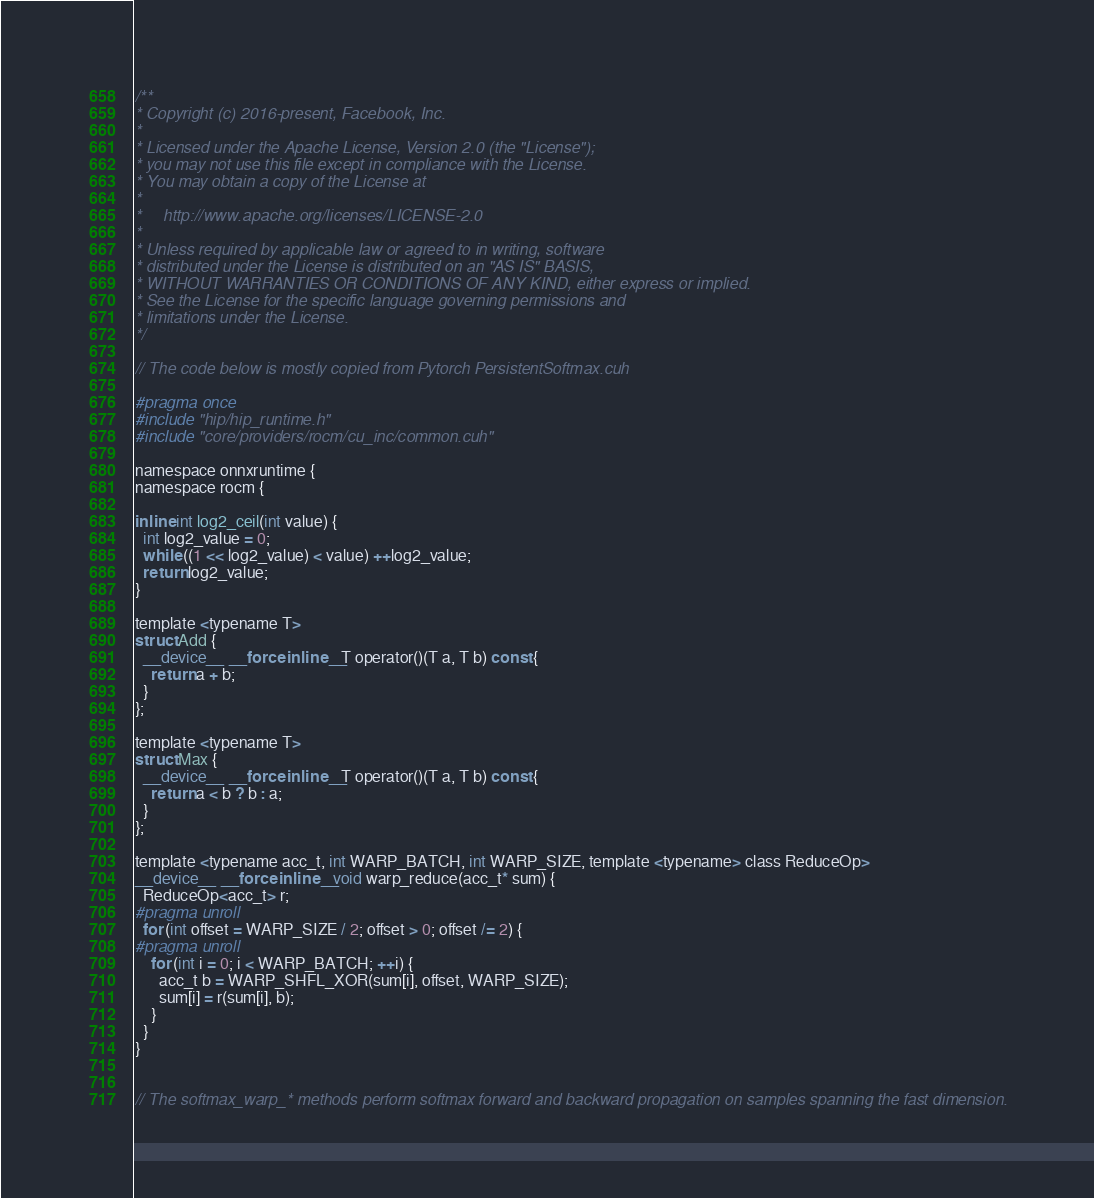Convert code to text. <code><loc_0><loc_0><loc_500><loc_500><_Cuda_>/**
* Copyright (c) 2016-present, Facebook, Inc.
*
* Licensed under the Apache License, Version 2.0 (the "License");
* you may not use this file except in compliance with the License.
* You may obtain a copy of the License at
*
*     http://www.apache.org/licenses/LICENSE-2.0
*
* Unless required by applicable law or agreed to in writing, software
* distributed under the License is distributed on an "AS IS" BASIS,
* WITHOUT WARRANTIES OR CONDITIONS OF ANY KIND, either express or implied.
* See the License for the specific language governing permissions and
* limitations under the License.
*/

// The code below is mostly copied from Pytorch PersistentSoftmax.cuh

#pragma once
#include "hip/hip_runtime.h"
#include "core/providers/rocm/cu_inc/common.cuh"

namespace onnxruntime {
namespace rocm {

inline int log2_ceil(int value) {
  int log2_value = 0;
  while ((1 << log2_value) < value) ++log2_value;
  return log2_value;
}

template <typename T>
struct Add {
  __device__ __forceinline__ T operator()(T a, T b) const {
    return a + b;
  }
};

template <typename T>
struct Max {
  __device__ __forceinline__ T operator()(T a, T b) const {
    return a < b ? b : a;
  }
};

template <typename acc_t, int WARP_BATCH, int WARP_SIZE, template <typename> class ReduceOp>
__device__ __forceinline__ void warp_reduce(acc_t* sum) {
  ReduceOp<acc_t> r;
#pragma unroll
  for (int offset = WARP_SIZE / 2; offset > 0; offset /= 2) {
#pragma unroll
    for (int i = 0; i < WARP_BATCH; ++i) {
      acc_t b = WARP_SHFL_XOR(sum[i], offset, WARP_SIZE);
      sum[i] = r(sum[i], b);
    }
  }
}


// The softmax_warp_* methods perform softmax forward and backward propagation on samples spanning the fast dimension.</code> 